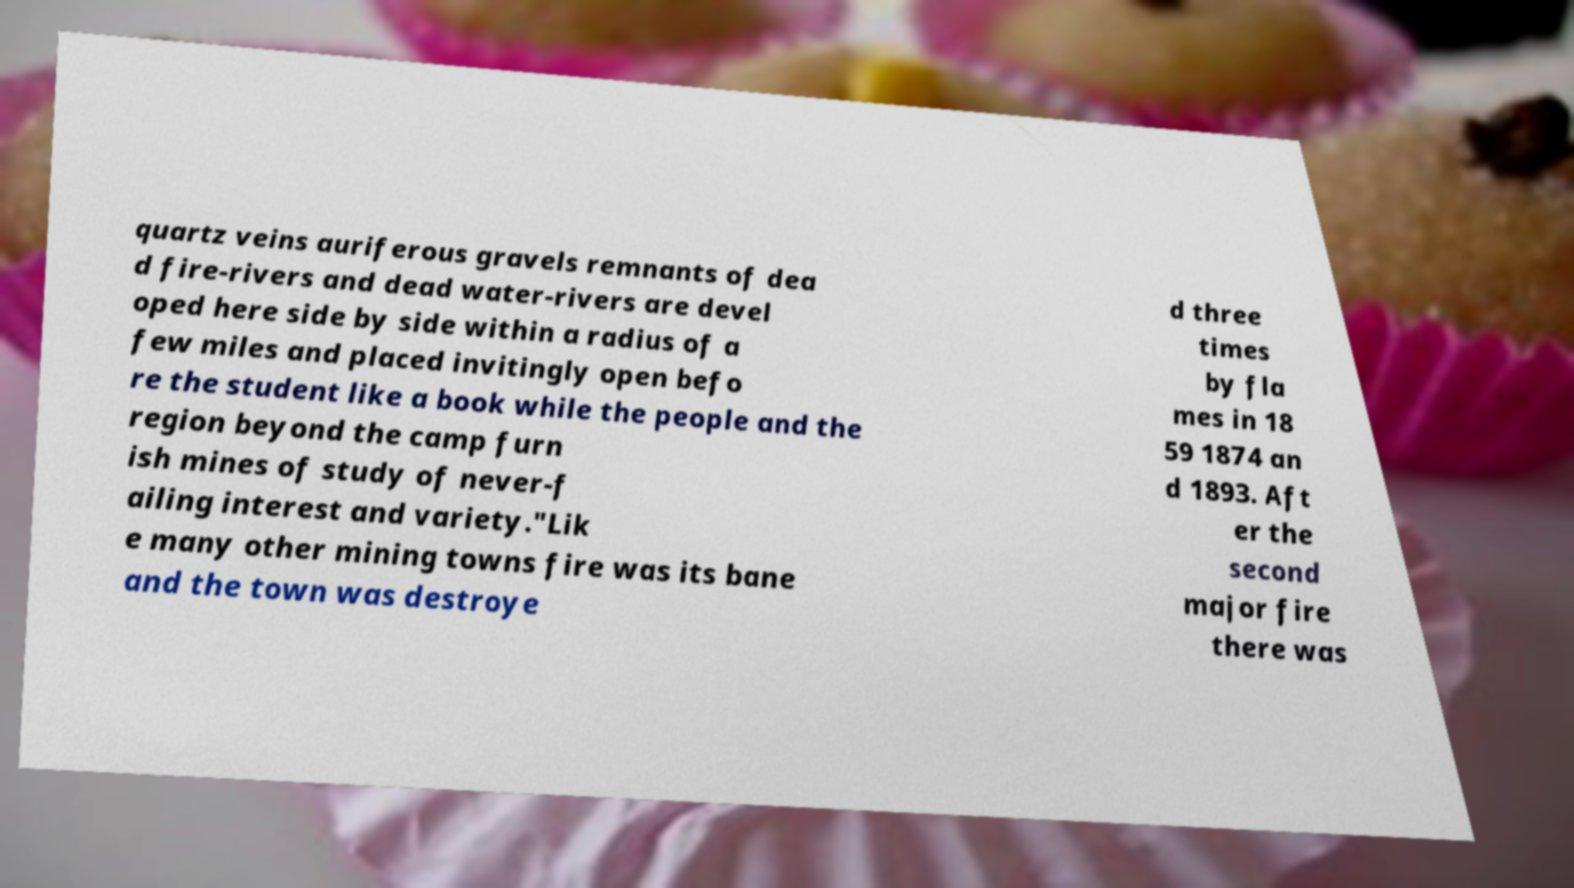Please identify and transcribe the text found in this image. quartz veins auriferous gravels remnants of dea d fire-rivers and dead water-rivers are devel oped here side by side within a radius of a few miles and placed invitingly open befo re the student like a book while the people and the region beyond the camp furn ish mines of study of never-f ailing interest and variety."Lik e many other mining towns fire was its bane and the town was destroye d three times by fla mes in 18 59 1874 an d 1893. Aft er the second major fire there was 